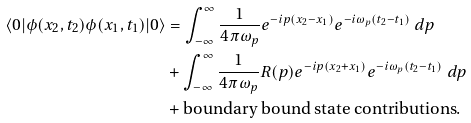<formula> <loc_0><loc_0><loc_500><loc_500>\langle 0 | \phi ( x _ { 2 } , t _ { 2 } ) \phi ( x _ { 1 } , t _ { 1 } ) | 0 \rangle & = \int _ { - \infty } ^ { \infty } \frac { 1 } { 4 \pi \omega _ { p } } e ^ { - i p ( x _ { 2 } - x _ { 1 } ) } e ^ { - i \omega _ { p } ( t _ { 2 } - t _ { 1 } ) } \ d p \\ & + \int _ { - \infty } ^ { \infty } \frac { 1 } { 4 \pi \omega _ { p } } R ( p ) e ^ { - i p ( x _ { 2 } + x _ { 1 } ) } e ^ { - i \omega _ { p } ( t _ { 2 } - t _ { 1 } ) } \ d p \\ & + \text {boundary bound state contributions.}</formula> 